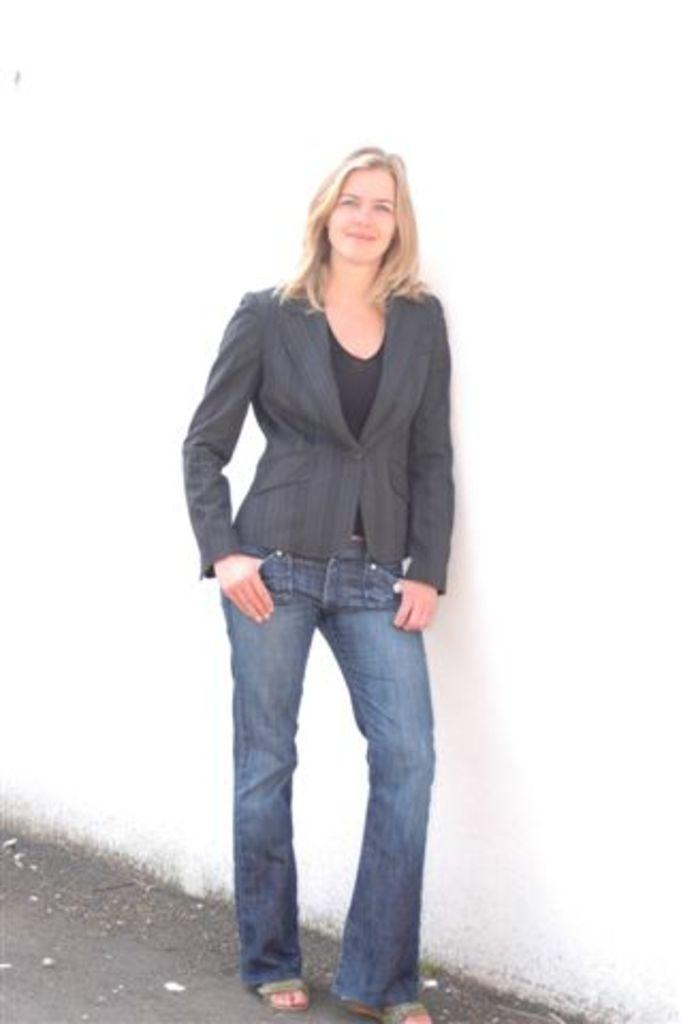Who is present in the image? There is a woman in the image. What is the woman doing in the image? The woman is standing in the image. What is the woman's facial expression in the image? The woman is smiling in the image. What can be seen in the background of the image? There is a wall in the background of the image. What type of crate is the woman holding in the image? There is no crate present in the image. What feeling does the woman express in the image? The woman is smiling, which generally indicates a positive feeling, but we cannot determine the exact feeling from the image alone. 